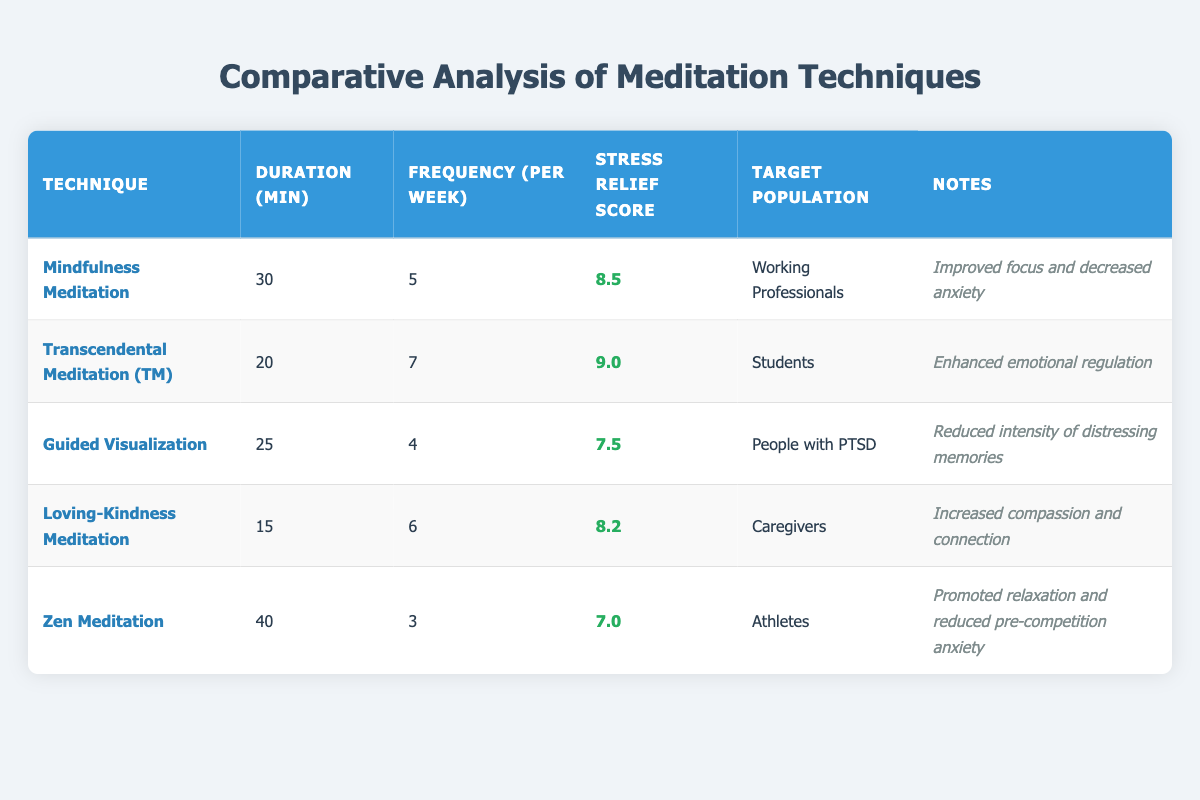What is the reported stress relief score for Loving-Kindness Meditation? According to the table, the stress relief score listed for Loving-Kindness Meditation is 8.2.
Answer: 8.2 How many minutes duration is required for Transcendental Meditation? The table shows that Transcendental Meditation requires a duration of 20 minutes.
Answer: 20 Which meditation technique has the highest reported stress relief score? Upon reviewing the stress relief scores, Transcendental Meditation has the highest score of 9.0 compared to others.
Answer: Transcendental Meditation What is the average stress relief score of all meditation techniques? To find the average, add all reported scores (8.5 + 9.0 + 7.5 + 8.2 + 7.0 = 40.2) and then divide by the number of techniques (40.2 / 5 = 8.04).
Answer: 8.04 Is the frequency of practice greater for Mindfulness Meditation compared to Zen Meditation? The frequency for Mindfulness Meditation is 5 times per week while for Zen Meditation it's 3 times per week, indicating that Mindfulness Meditation is practiced more frequently.
Answer: Yes Which target population benefits from Guided Visualization? The table indicates that Guided Visualization is aimed at people with PTSD.
Answer: People with PTSD Does Loving-Kindness Meditation have a higher duration requirement than Guided Visualization? Loving-Kindness Meditation is 15 minutes and Guided Visualization is 25 minutes, which means Guided Visualization requires a longer duration.
Answer: No What is the difference in reported stress relief scores between Mindfulness Meditation and Zen Meditation? Mindfulness Meditation has a score of 8.5 and Zen Meditation has a score of 7.0. The difference is (8.5 - 7.0 = 1.5).
Answer: 1.5 Which meditation technique has the highest frequency of practice per week? Transcendental Meditation, with a frequency of 7 times per week, has the highest frequency compared to others.
Answer: Transcendental Meditation 